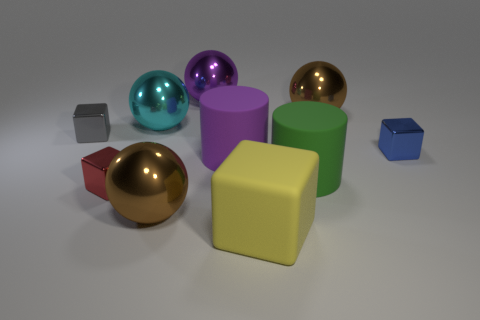Subtract 2 spheres. How many spheres are left? 2 Subtract all matte cubes. How many cubes are left? 3 Subtract all cyan balls. How many balls are left? 3 Subtract all brown cubes. Subtract all red cylinders. How many cubes are left? 4 Subtract all spheres. How many objects are left? 6 Add 6 big brown metallic things. How many big brown metallic things exist? 8 Subtract 0 green spheres. How many objects are left? 10 Subtract all gray spheres. Subtract all large brown metal balls. How many objects are left? 8 Add 2 large green matte things. How many large green matte things are left? 3 